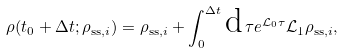Convert formula to latex. <formula><loc_0><loc_0><loc_500><loc_500>\rho ( t _ { 0 } + \Delta t ; \rho _ { \text {ss} , i } ) = \rho _ { \text {ss} , i } + \int _ { 0 } ^ { \Delta t } \text {d} \, \tau e ^ { \mathcal { L } _ { 0 } \tau } \mathcal { L } _ { 1 } \rho _ { \text {ss} , i } ,</formula> 